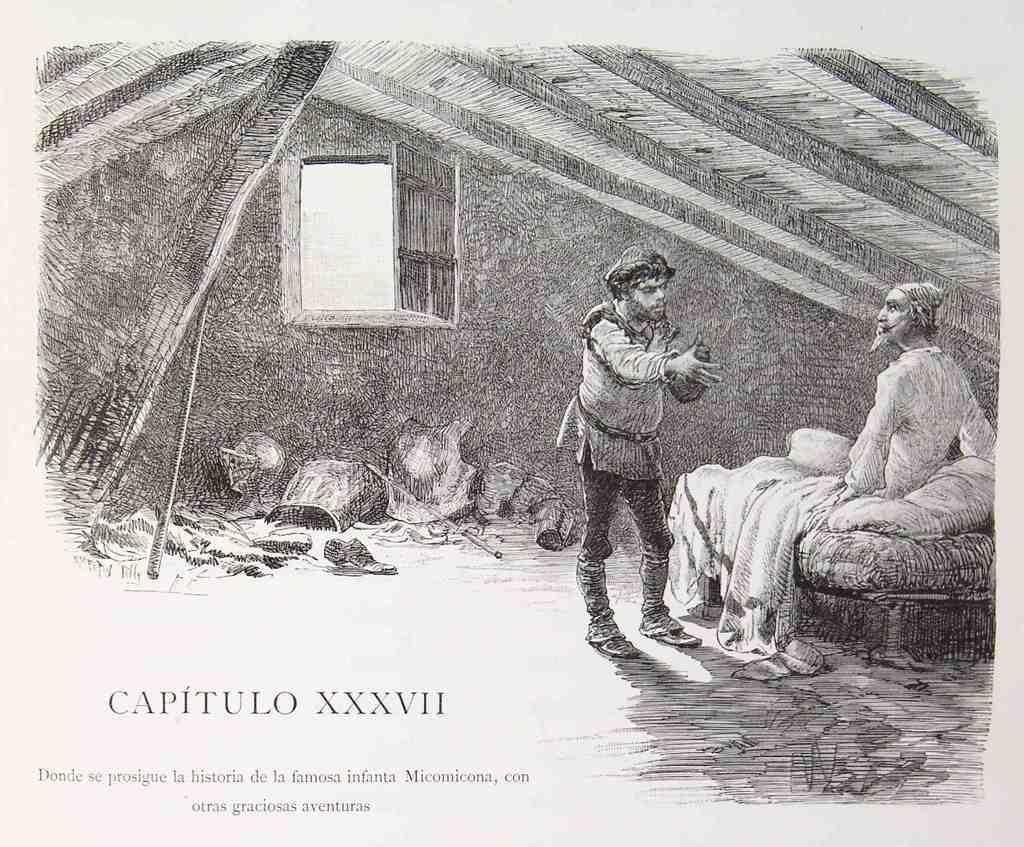Describe this image in one or two sentences. In this image we can see the drawing and in this we can see two persons. One is standing and the other is sitting on the bed. In the background we can see the window, wall, sticks and some other objects. We can also see the roof. At the bottom there is text. 